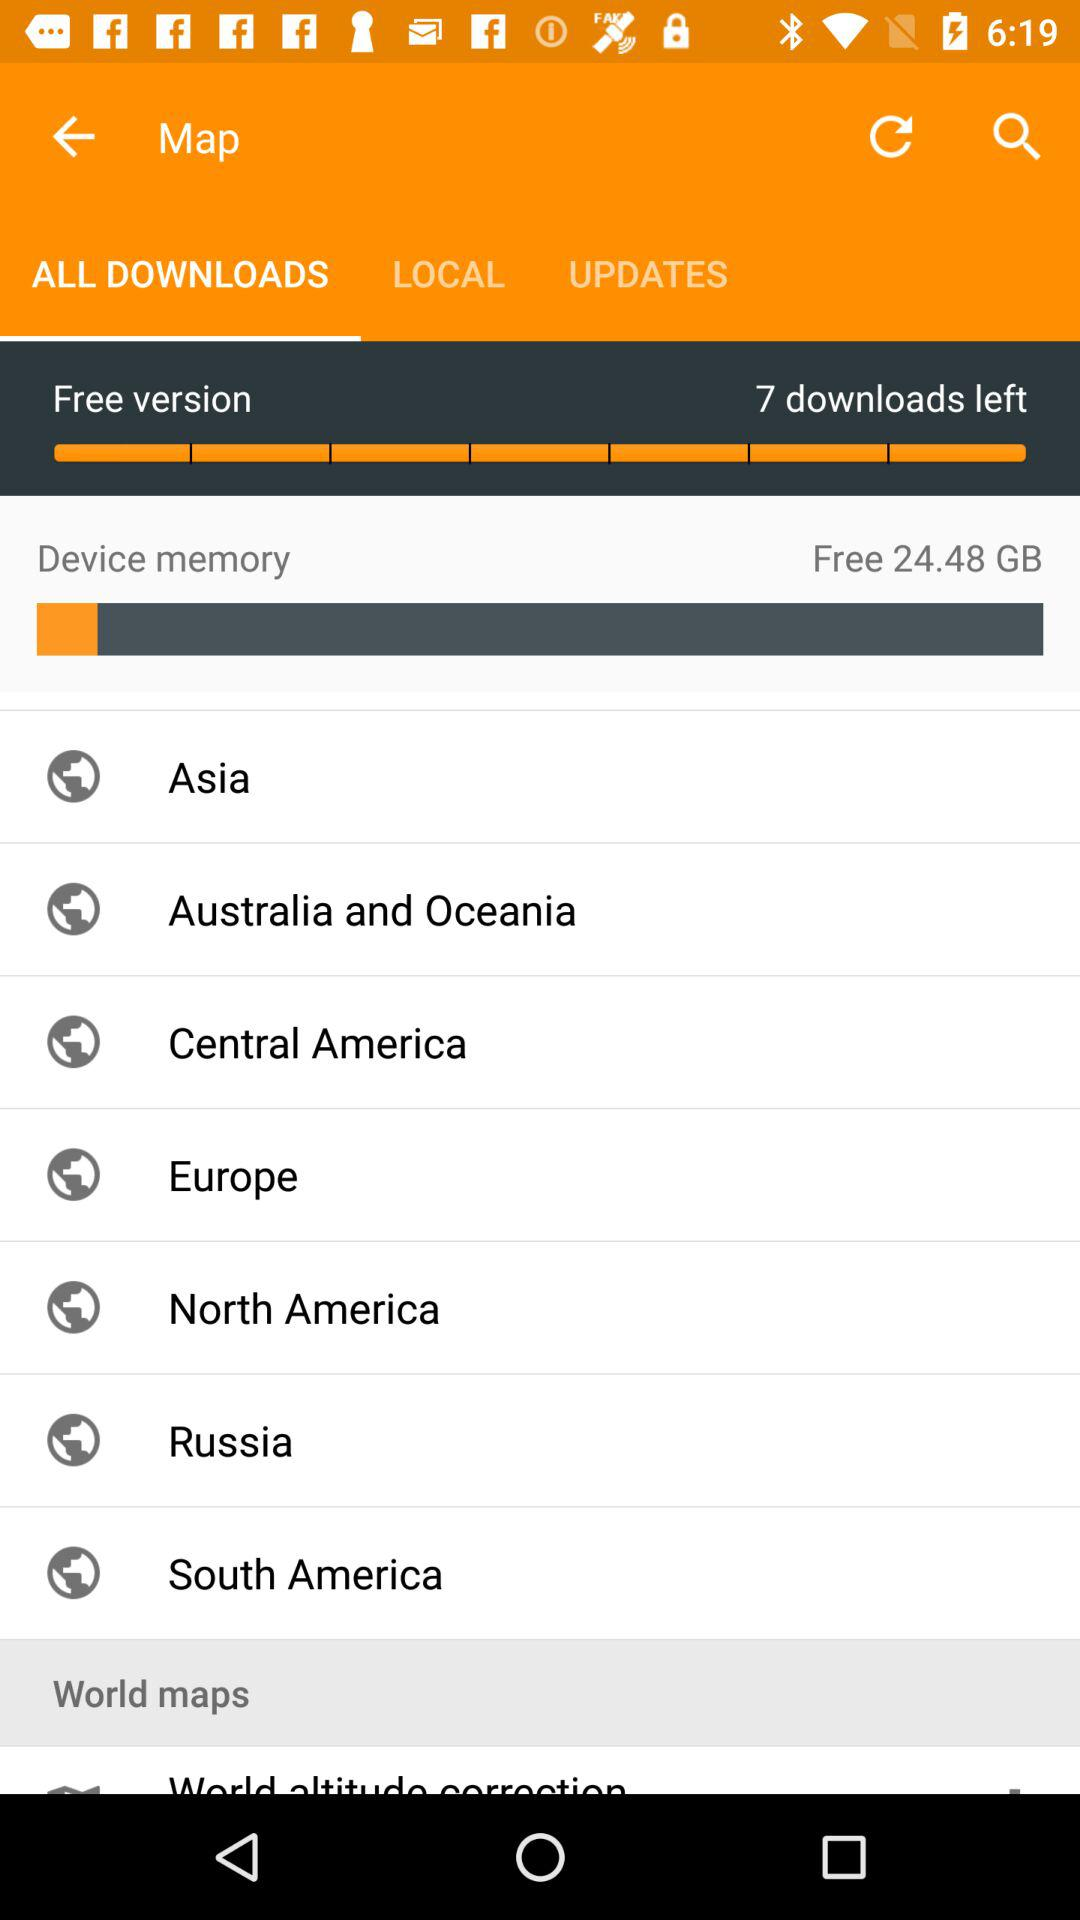What is the name of the application?
When the provided information is insufficient, respond with <no answer>. <no answer> 